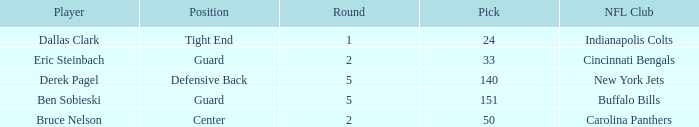Can you give me this table as a dict? {'header': ['Player', 'Position', 'Round', 'Pick', 'NFL Club'], 'rows': [['Dallas Clark', 'Tight End', '1', '24', 'Indianapolis Colts'], ['Eric Steinbach', 'Guard', '2', '33', 'Cincinnati Bengals'], ['Derek Pagel', 'Defensive Back', '5', '140', 'New York Jets'], ['Ben Sobieski', 'Guard', '5', '151', 'Buffalo Bills'], ['Bruce Nelson', 'Center', '2', '50', 'Carolina Panthers']]} What was the latest round that Derek Pagel was selected with a pick higher than 50? 5.0. 